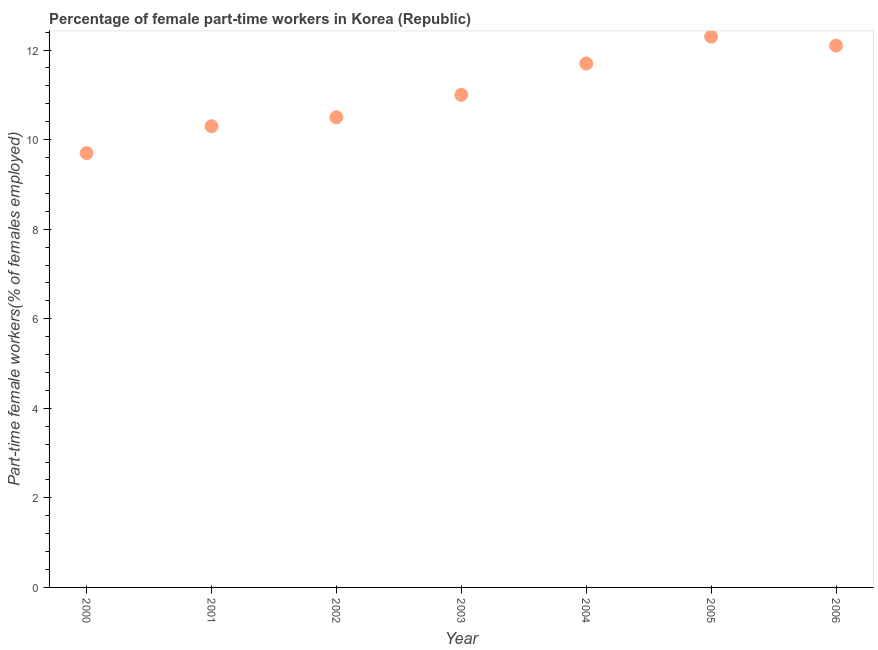What is the percentage of part-time female workers in 2006?
Your answer should be compact. 12.1. Across all years, what is the maximum percentage of part-time female workers?
Your answer should be compact. 12.3. Across all years, what is the minimum percentage of part-time female workers?
Offer a terse response. 9.7. In which year was the percentage of part-time female workers maximum?
Keep it short and to the point. 2005. In which year was the percentage of part-time female workers minimum?
Offer a very short reply. 2000. What is the sum of the percentage of part-time female workers?
Give a very brief answer. 77.6. What is the difference between the percentage of part-time female workers in 2000 and 2006?
Make the answer very short. -2.4. What is the average percentage of part-time female workers per year?
Keep it short and to the point. 11.09. What is the median percentage of part-time female workers?
Give a very brief answer. 11. In how many years, is the percentage of part-time female workers greater than 2.8 %?
Offer a very short reply. 7. Do a majority of the years between 2005 and 2000 (inclusive) have percentage of part-time female workers greater than 8.4 %?
Provide a succinct answer. Yes. What is the ratio of the percentage of part-time female workers in 2000 to that in 2001?
Offer a very short reply. 0.94. Is the percentage of part-time female workers in 2004 less than that in 2006?
Provide a succinct answer. Yes. Is the difference between the percentage of part-time female workers in 2000 and 2006 greater than the difference between any two years?
Your response must be concise. No. What is the difference between the highest and the second highest percentage of part-time female workers?
Offer a very short reply. 0.2. Is the sum of the percentage of part-time female workers in 2004 and 2005 greater than the maximum percentage of part-time female workers across all years?
Make the answer very short. Yes. What is the difference between the highest and the lowest percentage of part-time female workers?
Ensure brevity in your answer.  2.6. In how many years, is the percentage of part-time female workers greater than the average percentage of part-time female workers taken over all years?
Keep it short and to the point. 3. How many dotlines are there?
Provide a short and direct response. 1. Are the values on the major ticks of Y-axis written in scientific E-notation?
Offer a terse response. No. What is the title of the graph?
Your answer should be compact. Percentage of female part-time workers in Korea (Republic). What is the label or title of the X-axis?
Your answer should be very brief. Year. What is the label or title of the Y-axis?
Offer a terse response. Part-time female workers(% of females employed). What is the Part-time female workers(% of females employed) in 2000?
Ensure brevity in your answer.  9.7. What is the Part-time female workers(% of females employed) in 2001?
Make the answer very short. 10.3. What is the Part-time female workers(% of females employed) in 2002?
Offer a very short reply. 10.5. What is the Part-time female workers(% of females employed) in 2003?
Your answer should be compact. 11. What is the Part-time female workers(% of females employed) in 2004?
Provide a succinct answer. 11.7. What is the Part-time female workers(% of females employed) in 2005?
Offer a very short reply. 12.3. What is the Part-time female workers(% of females employed) in 2006?
Provide a short and direct response. 12.1. What is the difference between the Part-time female workers(% of females employed) in 2000 and 2002?
Your answer should be very brief. -0.8. What is the difference between the Part-time female workers(% of females employed) in 2000 and 2003?
Ensure brevity in your answer.  -1.3. What is the difference between the Part-time female workers(% of females employed) in 2000 and 2004?
Your answer should be very brief. -2. What is the difference between the Part-time female workers(% of females employed) in 2000 and 2006?
Offer a very short reply. -2.4. What is the difference between the Part-time female workers(% of females employed) in 2001 and 2002?
Make the answer very short. -0.2. What is the difference between the Part-time female workers(% of females employed) in 2001 and 2005?
Keep it short and to the point. -2. What is the difference between the Part-time female workers(% of females employed) in 2001 and 2006?
Provide a succinct answer. -1.8. What is the difference between the Part-time female workers(% of females employed) in 2002 and 2004?
Ensure brevity in your answer.  -1.2. What is the difference between the Part-time female workers(% of females employed) in 2002 and 2006?
Offer a very short reply. -1.6. What is the difference between the Part-time female workers(% of females employed) in 2004 and 2005?
Make the answer very short. -0.6. What is the difference between the Part-time female workers(% of females employed) in 2004 and 2006?
Give a very brief answer. -0.4. What is the ratio of the Part-time female workers(% of females employed) in 2000 to that in 2001?
Provide a succinct answer. 0.94. What is the ratio of the Part-time female workers(% of females employed) in 2000 to that in 2002?
Ensure brevity in your answer.  0.92. What is the ratio of the Part-time female workers(% of females employed) in 2000 to that in 2003?
Give a very brief answer. 0.88. What is the ratio of the Part-time female workers(% of females employed) in 2000 to that in 2004?
Offer a terse response. 0.83. What is the ratio of the Part-time female workers(% of females employed) in 2000 to that in 2005?
Your answer should be compact. 0.79. What is the ratio of the Part-time female workers(% of females employed) in 2000 to that in 2006?
Offer a terse response. 0.8. What is the ratio of the Part-time female workers(% of females employed) in 2001 to that in 2002?
Your response must be concise. 0.98. What is the ratio of the Part-time female workers(% of females employed) in 2001 to that in 2003?
Offer a terse response. 0.94. What is the ratio of the Part-time female workers(% of females employed) in 2001 to that in 2005?
Ensure brevity in your answer.  0.84. What is the ratio of the Part-time female workers(% of females employed) in 2001 to that in 2006?
Provide a succinct answer. 0.85. What is the ratio of the Part-time female workers(% of females employed) in 2002 to that in 2003?
Provide a short and direct response. 0.95. What is the ratio of the Part-time female workers(% of females employed) in 2002 to that in 2004?
Your answer should be very brief. 0.9. What is the ratio of the Part-time female workers(% of females employed) in 2002 to that in 2005?
Your response must be concise. 0.85. What is the ratio of the Part-time female workers(% of females employed) in 2002 to that in 2006?
Offer a terse response. 0.87. What is the ratio of the Part-time female workers(% of females employed) in 2003 to that in 2005?
Offer a terse response. 0.89. What is the ratio of the Part-time female workers(% of females employed) in 2003 to that in 2006?
Ensure brevity in your answer.  0.91. What is the ratio of the Part-time female workers(% of females employed) in 2004 to that in 2005?
Provide a succinct answer. 0.95. What is the ratio of the Part-time female workers(% of females employed) in 2004 to that in 2006?
Ensure brevity in your answer.  0.97. 